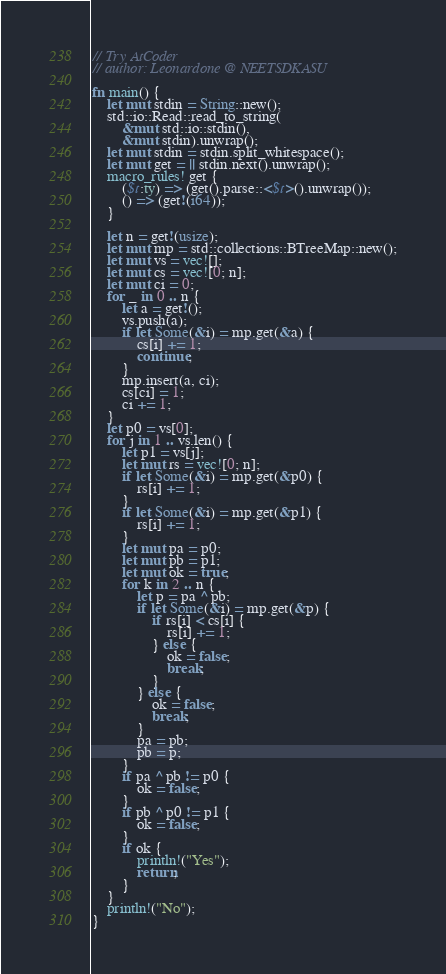Convert code to text. <code><loc_0><loc_0><loc_500><loc_500><_Rust_>// Try AtCoder
// author: Leonardone @ NEETSDKASU

fn main() {
    let mut stdin = String::new();
    std::io::Read::read_to_string(
        &mut std::io::stdin(),
        &mut stdin).unwrap();
    let mut stdin = stdin.split_whitespace();
    let mut get = || stdin.next().unwrap();
    macro_rules! get {
        ($t:ty) => (get().parse::<$t>().unwrap());
        () => (get!(i64));
    }
    
    let n = get!(usize);
    let mut mp = std::collections::BTreeMap::new();
    let mut vs = vec![];
    let mut cs = vec![0; n];
    let mut ci = 0;
    for _ in 0 .. n {
    	let a = get!();
        vs.push(a);
        if let Some(&i) = mp.get(&a) {
            cs[i] += 1;
            continue;
        }
        mp.insert(a, ci);
        cs[ci] = 1;
        ci += 1;
    }
    let p0 = vs[0];
    for j in 1 .. vs.len() {
        let p1 = vs[j];
        let mut rs = vec![0; n];
        if let Some(&i) = mp.get(&p0) {
            rs[i] += 1;
        }
        if let Some(&i) = mp.get(&p1) {
            rs[i] += 1;
        }
        let mut pa = p0;
        let mut pb = p1;
        let mut ok = true;
        for k in 2 .. n {
            let p = pa ^ pb;
            if let Some(&i) = mp.get(&p) {
                if rs[i] < cs[i] {
                    rs[i] += 1;
                } else {
                    ok = false;
                    break;
                }
            } else {
                ok = false;
                break;
            }
            pa = pb;
            pb = p;
        }
        if pa ^ pb != p0 {
            ok = false;
        }
        if pb ^ p0 != p1 {
            ok = false;
        }
        if ok {
            println!("Yes");
            return;
        }
    }
    println!("No");
}</code> 